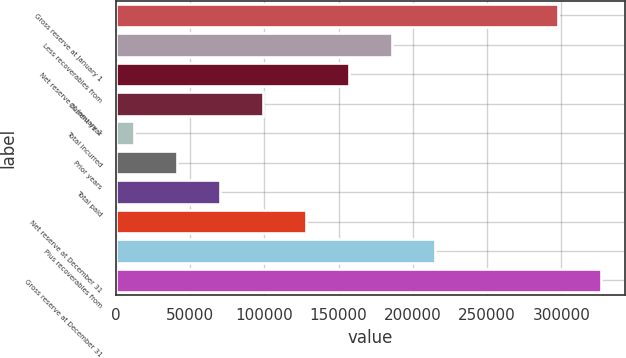Convert chart to OTSL. <chart><loc_0><loc_0><loc_500><loc_500><bar_chart><fcel>Gross reserve at January 1<fcel>Less recoverables from<fcel>Net reserve at January 1<fcel>Current year<fcel>Total incurred<fcel>Prior years<fcel>Total paid<fcel>Net reserve at December 31<fcel>Plus recoverables from<fcel>Gross reserve at December 31<nl><fcel>297699<fcel>185818<fcel>156894<fcel>99043.7<fcel>12269<fcel>41193.9<fcel>70118.8<fcel>127969<fcel>214743<fcel>326624<nl></chart> 